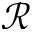Convert formula to latex. <formula><loc_0><loc_0><loc_500><loc_500>\mathcal { R }</formula> 